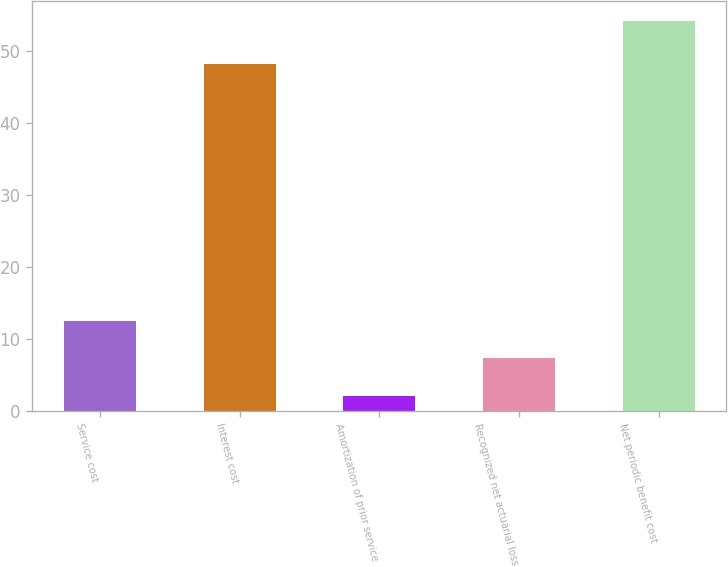<chart> <loc_0><loc_0><loc_500><loc_500><bar_chart><fcel>Service cost<fcel>Interest cost<fcel>Amortization of prior service<fcel>Recognized net actuarial loss<fcel>Net periodic benefit cost<nl><fcel>12.52<fcel>48.2<fcel>2.1<fcel>7.31<fcel>54.2<nl></chart> 